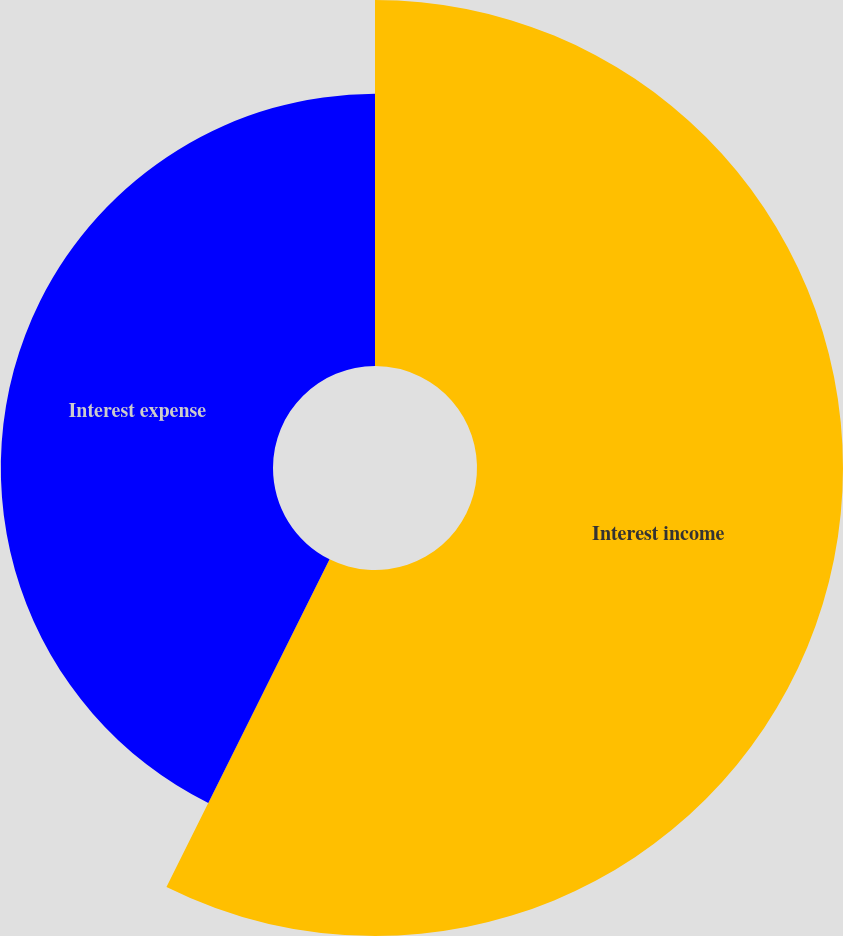<chart> <loc_0><loc_0><loc_500><loc_500><pie_chart><fcel>Interest income<fcel>Interest expense<nl><fcel>57.35%<fcel>42.65%<nl></chart> 